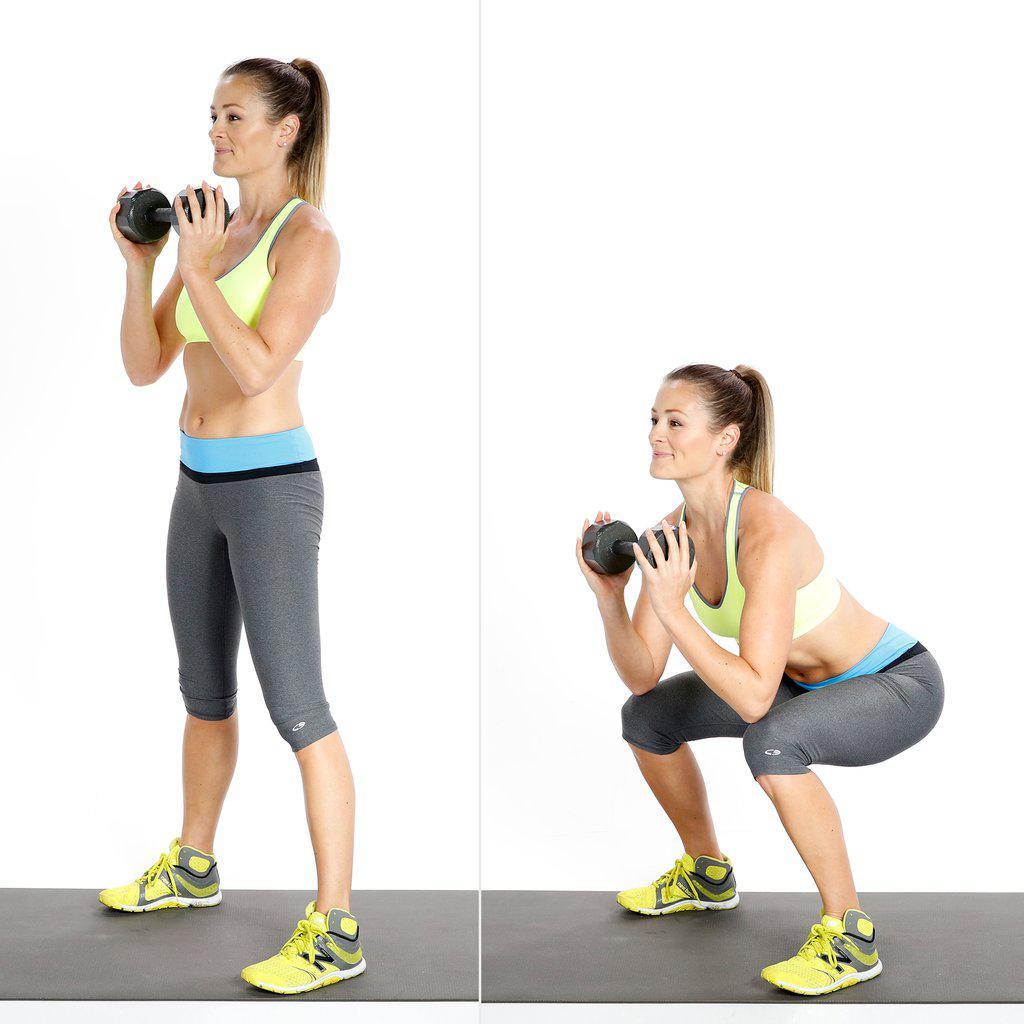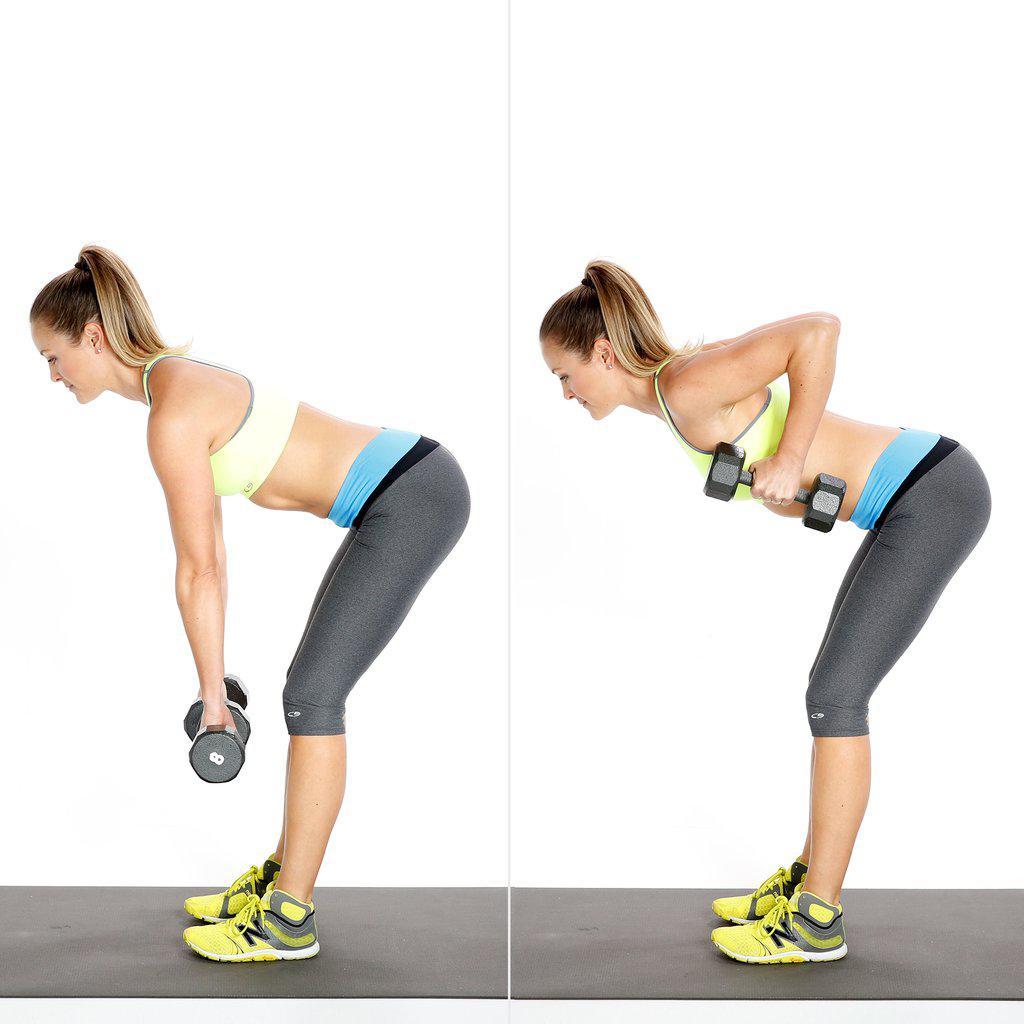The first image is the image on the left, the second image is the image on the right. Assess this claim about the two images: "The left and right image contains the same number of women using weights.". Correct or not? Answer yes or no. Yes. The first image is the image on the left, the second image is the image on the right. Examine the images to the left and right. Is the description "Each image shows a woman demonstrating at least two different positions in a dumbbell workout." accurate? Answer yes or no. Yes. 